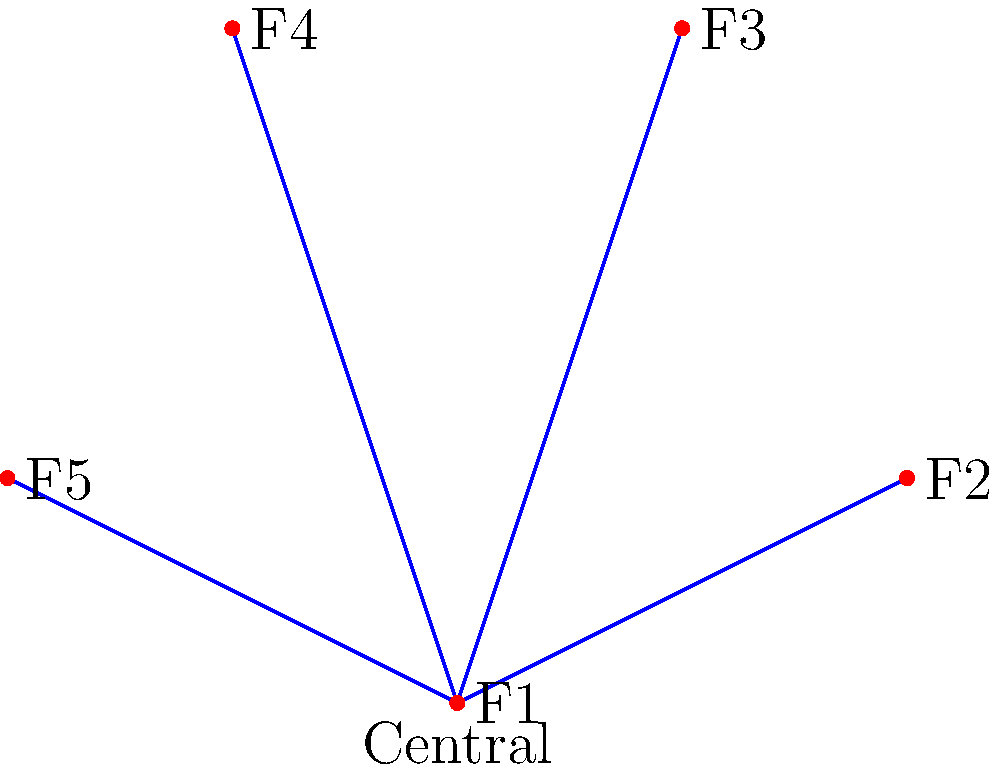In the X-COM research network shown above, five facilities (F1 to F5) are connected in a star topology with a central hub. Given that the cost of establishing a connection is proportional to its length, which facility should be chosen as the central hub to minimize the total connection cost? Assume the distance between any two adjacent facilities on the perimeter is 2 units. To determine the most efficient central hub, we need to calculate the total connection length for each facility acting as the hub. The facility with the lowest total connection length will be the most efficient choice.

Step 1: Calculate distances between facilities.
- F1 to F2: 2 units
- F2 to F3: 2 units
- F3 to F4: 2 units
- F4 to F5: 2 units
- F5 to F1: 2 units
- F1 to F3: $\sqrt{5}$ units
- F1 to F4: $\sqrt{5}$ units
- F2 to F4: $\sqrt{8}$ units
- F2 to F5: $\sqrt{8}$ units

Step 2: Calculate total connection length for each facility as the hub.
- F1 as hub: 2 + 2 + $\sqrt{5}$ + $\sqrt{5}$ + 2 = $4 + 2\sqrt{5}$ units
- F2 as hub: 2 + 2 + 2 + $\sqrt{8}$ + $\sqrt{8}$ = $6 + 2\sqrt{8}$ units
- F3 as hub: $\sqrt{5}$ + 2 + 2 + 2 + $\sqrt{8}$ = $6 + \sqrt{5} + \sqrt{8}$ units
- F4 as hub: $\sqrt{5}$ + $\sqrt{8}$ + 2 + 2 + 2 = $6 + \sqrt{5} + \sqrt{8}$ units
- F5 as hub: 2 + $\sqrt{8}$ + $\sqrt{8}$ + 2 + 2 = $6 + 2\sqrt{8}$ units

Step 3: Compare total connection lengths.
$4 + 2\sqrt{5}$ ≈ 8.47 units (F1)
$6 + 2\sqrt{8}$ ≈ 11.66 units (F2 and F5)
$6 + \sqrt{5} + \sqrt{8}$ ≈ 10.06 units (F3 and F4)

Therefore, F1 provides the lowest total connection length and is the most efficient choice for the central hub.
Answer: F1 